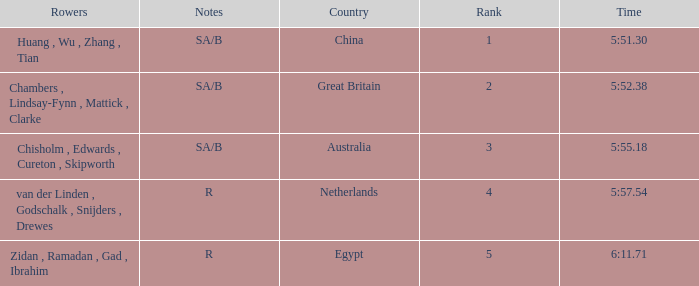Could you help me parse every detail presented in this table? {'header': ['Rowers', 'Notes', 'Country', 'Rank', 'Time'], 'rows': [['Huang , Wu , Zhang , Tian', 'SA/B', 'China', '1', '5:51.30'], ['Chambers , Lindsay-Fynn , Mattick , Clarke', 'SA/B', 'Great Britain', '2', '5:52.38'], ['Chisholm , Edwards , Cureton , Skipworth', 'SA/B', 'Australia', '3', '5:55.18'], ['van der Linden , Godschalk , Snijders , Drewes', 'R', 'Netherlands', '4', '5:57.54'], ['Zidan , Ramadan , Gad , Ibrahim', 'R', 'Egypt', '5', '6:11.71']]} Who were the rowers when notes were sa/b, with a time of 5:51.30? Huang , Wu , Zhang , Tian. 